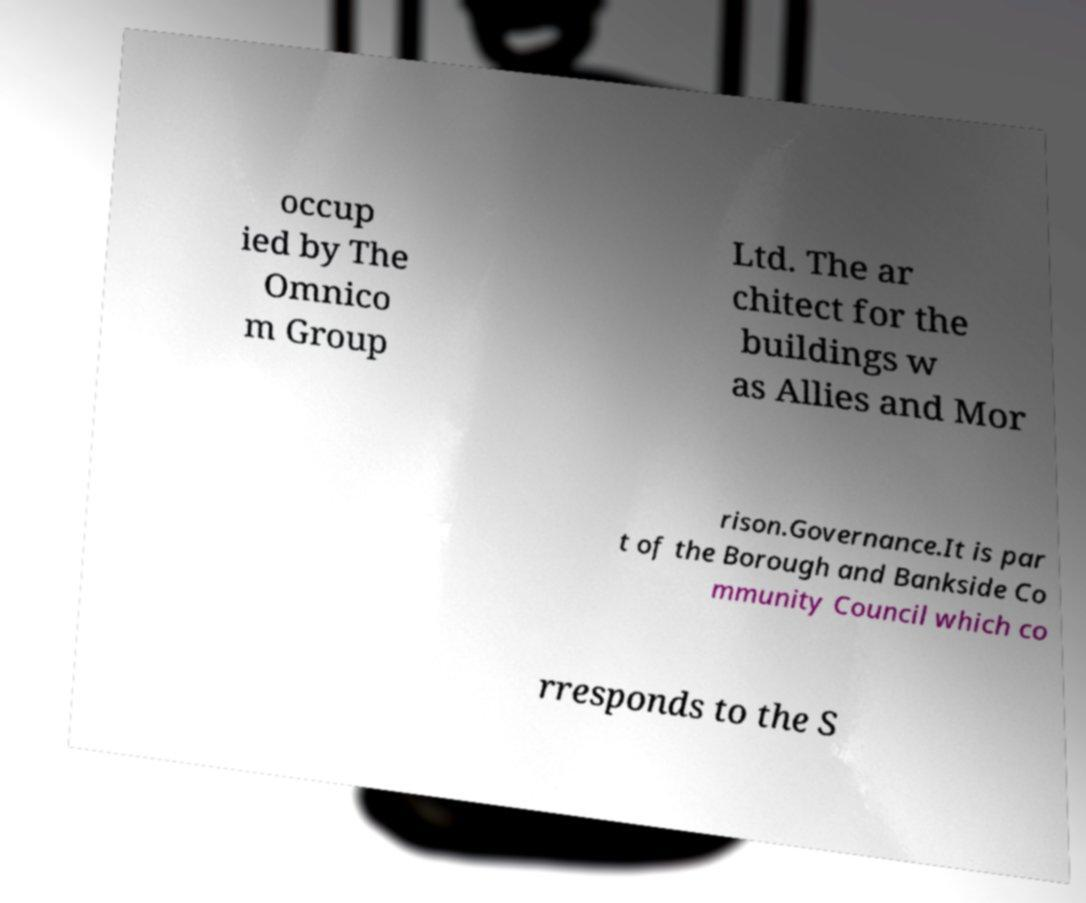Can you accurately transcribe the text from the provided image for me? occup ied by The Omnico m Group Ltd. The ar chitect for the buildings w as Allies and Mor rison.Governance.It is par t of the Borough and Bankside Co mmunity Council which co rresponds to the S 